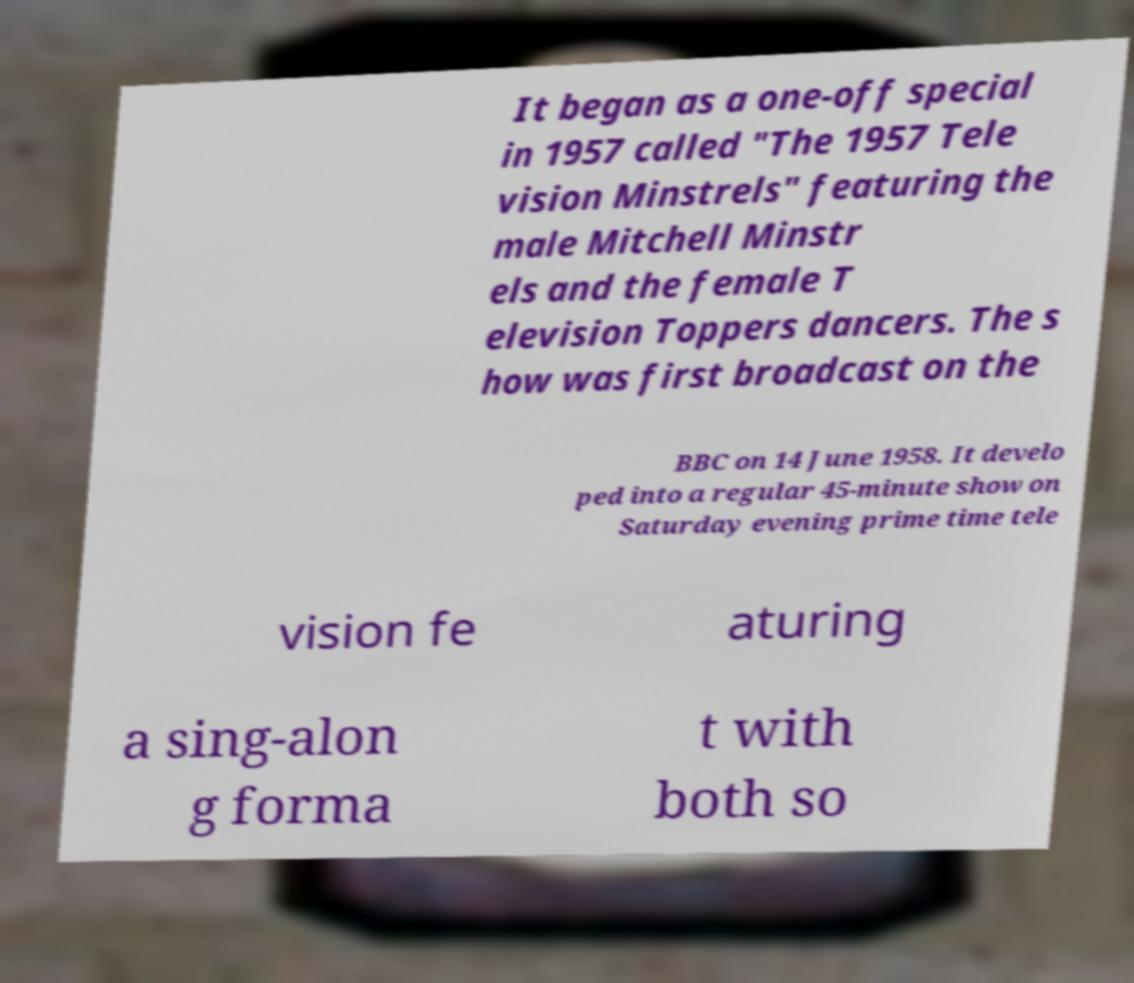Could you assist in decoding the text presented in this image and type it out clearly? It began as a one-off special in 1957 called "The 1957 Tele vision Minstrels" featuring the male Mitchell Minstr els and the female T elevision Toppers dancers. The s how was first broadcast on the BBC on 14 June 1958. It develo ped into a regular 45-minute show on Saturday evening prime time tele vision fe aturing a sing-alon g forma t with both so 